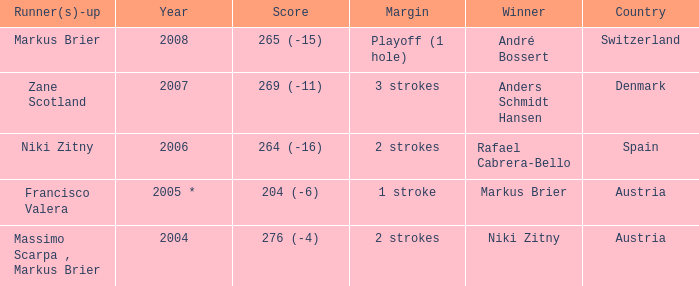What was the country when the margin was 2 strokes, and when the score was 276 (-4)? Austria. 